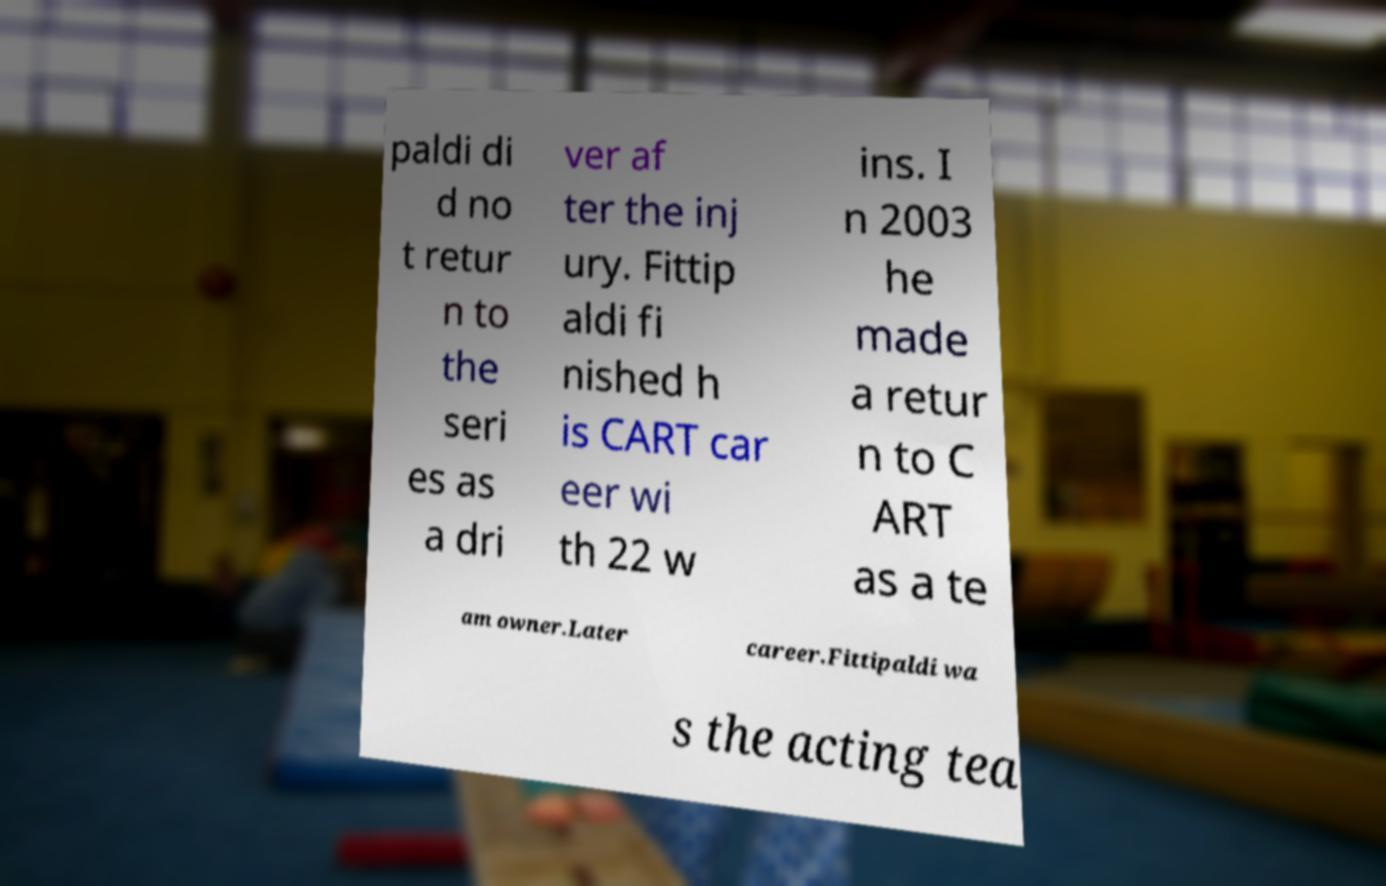Can you accurately transcribe the text from the provided image for me? paldi di d no t retur n to the seri es as a dri ver af ter the inj ury. Fittip aldi fi nished h is CART car eer wi th 22 w ins. I n 2003 he made a retur n to C ART as a te am owner.Later career.Fittipaldi wa s the acting tea 